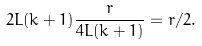Convert formula to latex. <formula><loc_0><loc_0><loc_500><loc_500>2 L ( k + 1 ) \frac { r } { 4 L ( k + 1 ) } = r / 2 .</formula> 